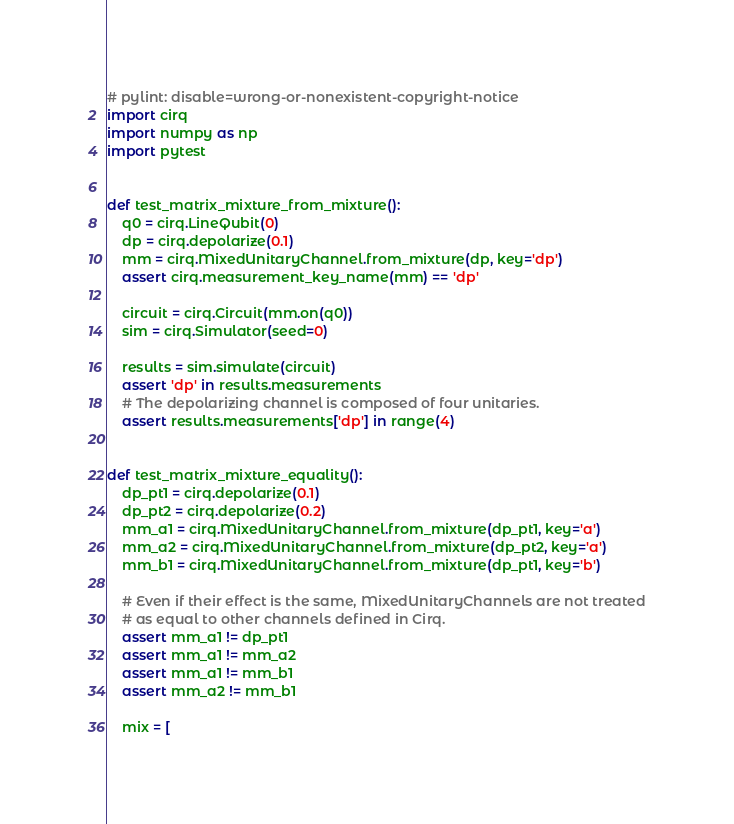<code> <loc_0><loc_0><loc_500><loc_500><_Python_># pylint: disable=wrong-or-nonexistent-copyright-notice
import cirq
import numpy as np
import pytest


def test_matrix_mixture_from_mixture():
    q0 = cirq.LineQubit(0)
    dp = cirq.depolarize(0.1)
    mm = cirq.MixedUnitaryChannel.from_mixture(dp, key='dp')
    assert cirq.measurement_key_name(mm) == 'dp'

    circuit = cirq.Circuit(mm.on(q0))
    sim = cirq.Simulator(seed=0)

    results = sim.simulate(circuit)
    assert 'dp' in results.measurements
    # The depolarizing channel is composed of four unitaries.
    assert results.measurements['dp'] in range(4)


def test_matrix_mixture_equality():
    dp_pt1 = cirq.depolarize(0.1)
    dp_pt2 = cirq.depolarize(0.2)
    mm_a1 = cirq.MixedUnitaryChannel.from_mixture(dp_pt1, key='a')
    mm_a2 = cirq.MixedUnitaryChannel.from_mixture(dp_pt2, key='a')
    mm_b1 = cirq.MixedUnitaryChannel.from_mixture(dp_pt1, key='b')

    # Even if their effect is the same, MixedUnitaryChannels are not treated
    # as equal to other channels defined in Cirq.
    assert mm_a1 != dp_pt1
    assert mm_a1 != mm_a2
    assert mm_a1 != mm_b1
    assert mm_a2 != mm_b1

    mix = [</code> 